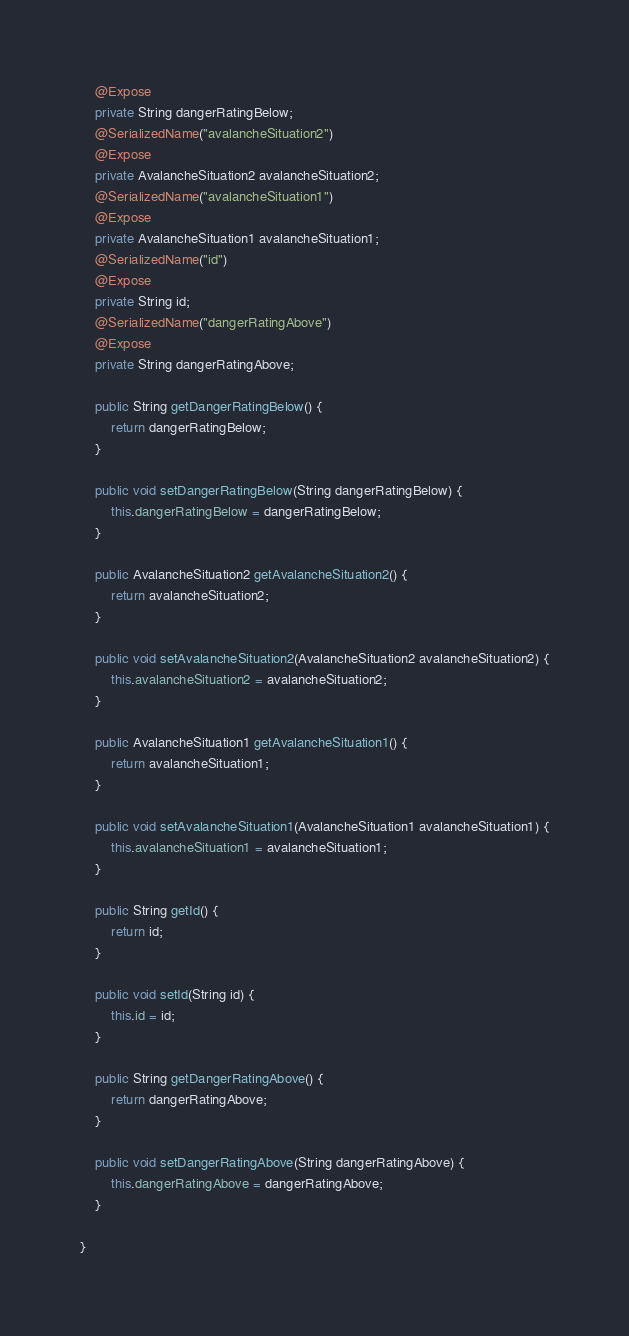Convert code to text. <code><loc_0><loc_0><loc_500><loc_500><_Java_>    @Expose
    private String dangerRatingBelow;
    @SerializedName("avalancheSituation2")
    @Expose
    private AvalancheSituation2 avalancheSituation2;
    @SerializedName("avalancheSituation1")
    @Expose
    private AvalancheSituation1 avalancheSituation1;
    @SerializedName("id")
    @Expose
    private String id;
    @SerializedName("dangerRatingAbove")
    @Expose
    private String dangerRatingAbove;

    public String getDangerRatingBelow() {
        return dangerRatingBelow;
    }

    public void setDangerRatingBelow(String dangerRatingBelow) {
        this.dangerRatingBelow = dangerRatingBelow;
    }

    public AvalancheSituation2 getAvalancheSituation2() {
        return avalancheSituation2;
    }

    public void setAvalancheSituation2(AvalancheSituation2 avalancheSituation2) {
        this.avalancheSituation2 = avalancheSituation2;
    }

    public AvalancheSituation1 getAvalancheSituation1() {
        return avalancheSituation1;
    }

    public void setAvalancheSituation1(AvalancheSituation1 avalancheSituation1) {
        this.avalancheSituation1 = avalancheSituation1;
    }

    public String getId() {
        return id;
    }

    public void setId(String id) {
        this.id = id;
    }

    public String getDangerRatingAbove() {
        return dangerRatingAbove;
    }

    public void setDangerRatingAbove(String dangerRatingAbove) {
        this.dangerRatingAbove = dangerRatingAbove;
    }

}
</code> 